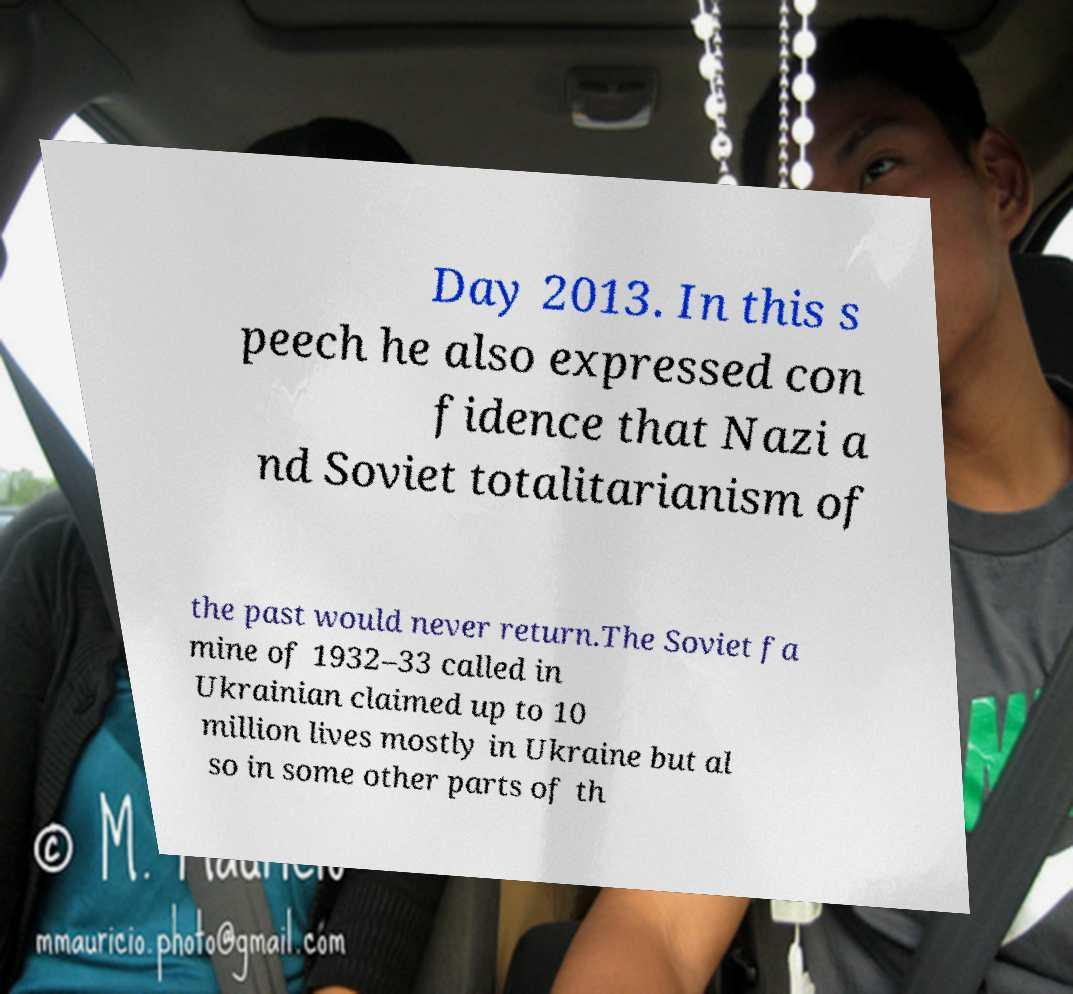There's text embedded in this image that I need extracted. Can you transcribe it verbatim? Day 2013. In this s peech he also expressed con fidence that Nazi a nd Soviet totalitarianism of the past would never return.The Soviet fa mine of 1932–33 called in Ukrainian claimed up to 10 million lives mostly in Ukraine but al so in some other parts of th 